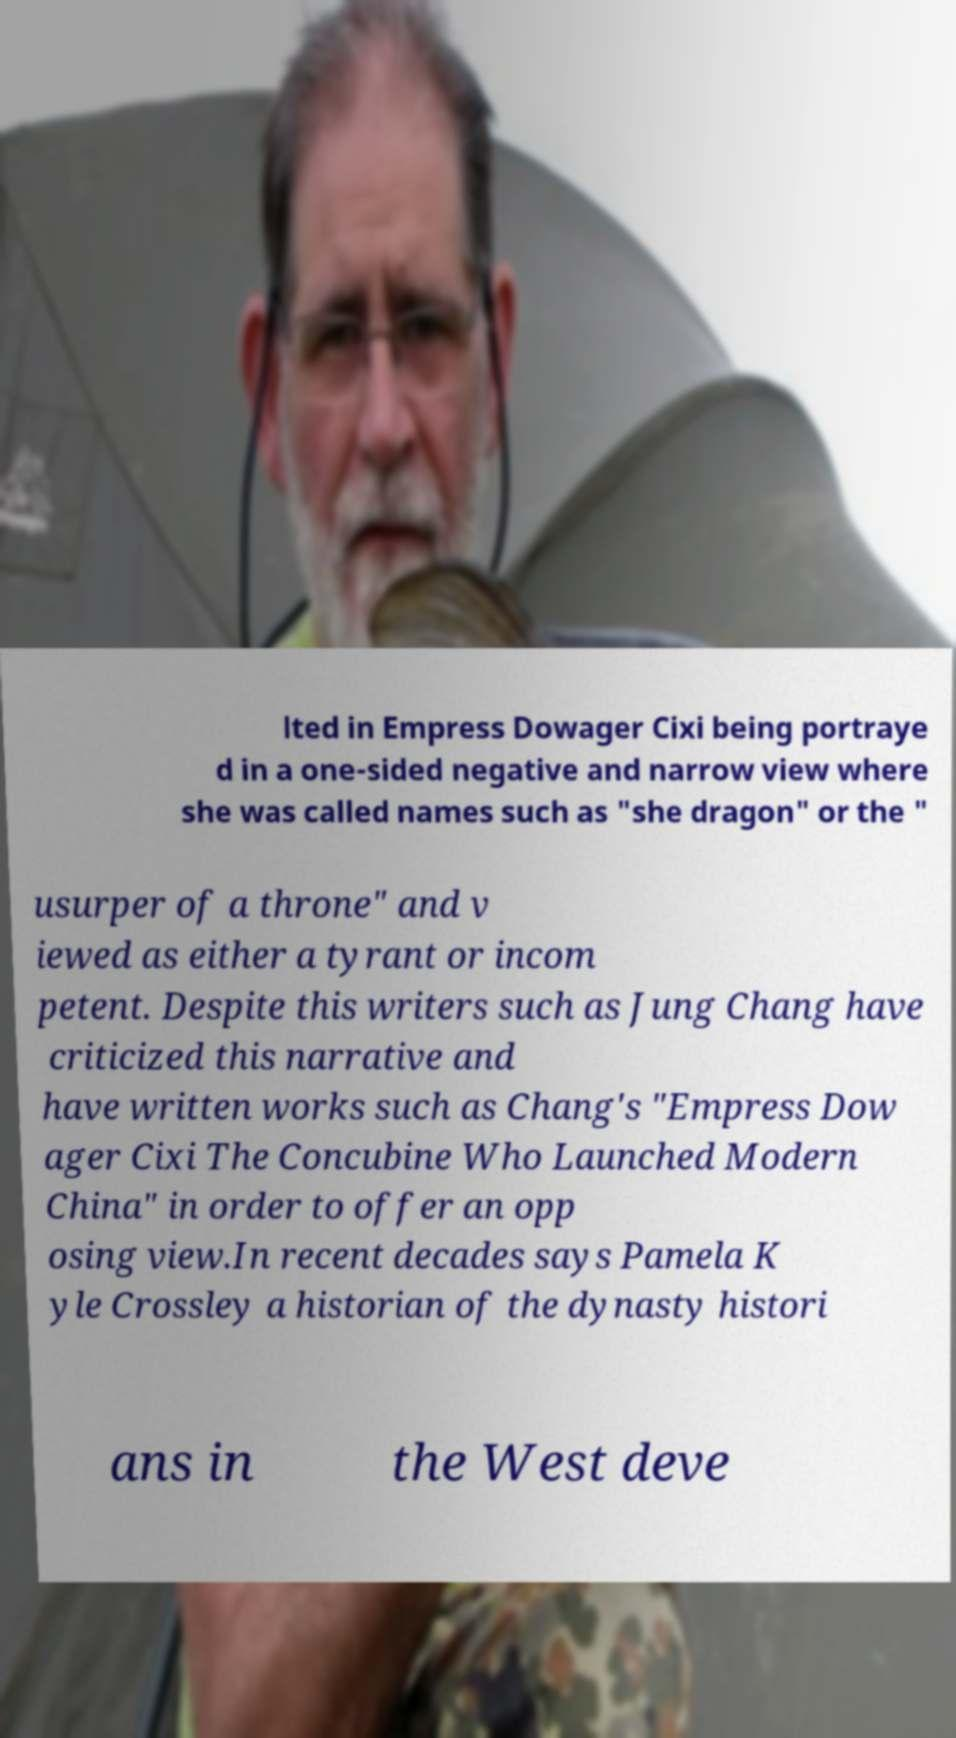What messages or text are displayed in this image? I need them in a readable, typed format. lted in Empress Dowager Cixi being portraye d in a one-sided negative and narrow view where she was called names such as "she dragon" or the " usurper of a throne" and v iewed as either a tyrant or incom petent. Despite this writers such as Jung Chang have criticized this narrative and have written works such as Chang's "Empress Dow ager Cixi The Concubine Who Launched Modern China" in order to offer an opp osing view.In recent decades says Pamela K yle Crossley a historian of the dynasty histori ans in the West deve 